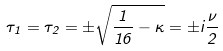Convert formula to latex. <formula><loc_0><loc_0><loc_500><loc_500>\tau _ { 1 } = \tau _ { 2 } = \pm \sqrt { \frac { 1 } { 1 6 } - \kappa } = \pm i \frac { \nu } { 2 }</formula> 